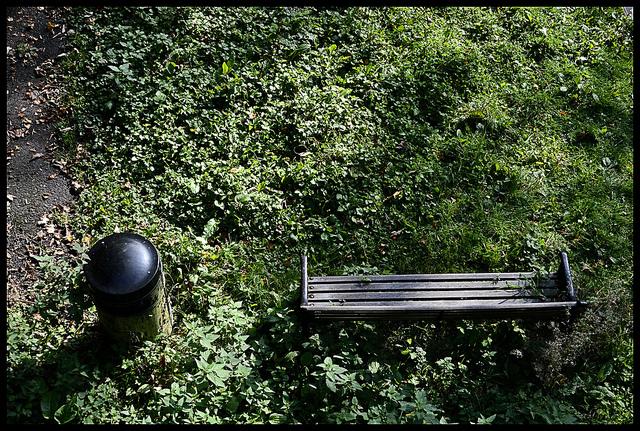Is the grass green?
Answer briefly. Yes. Is the camera taking the photo looking up or down?
Short answer required. Down. What time of year is it?
Be succinct. Summer. What season is it?
Write a very short answer. Spring. Is there any animals in this scene?
Be succinct. No. Is someone sitting on the bench?
Be succinct. No. What are those green things?
Answer briefly. Grass. What type of area is this?
Short answer required. Park. 